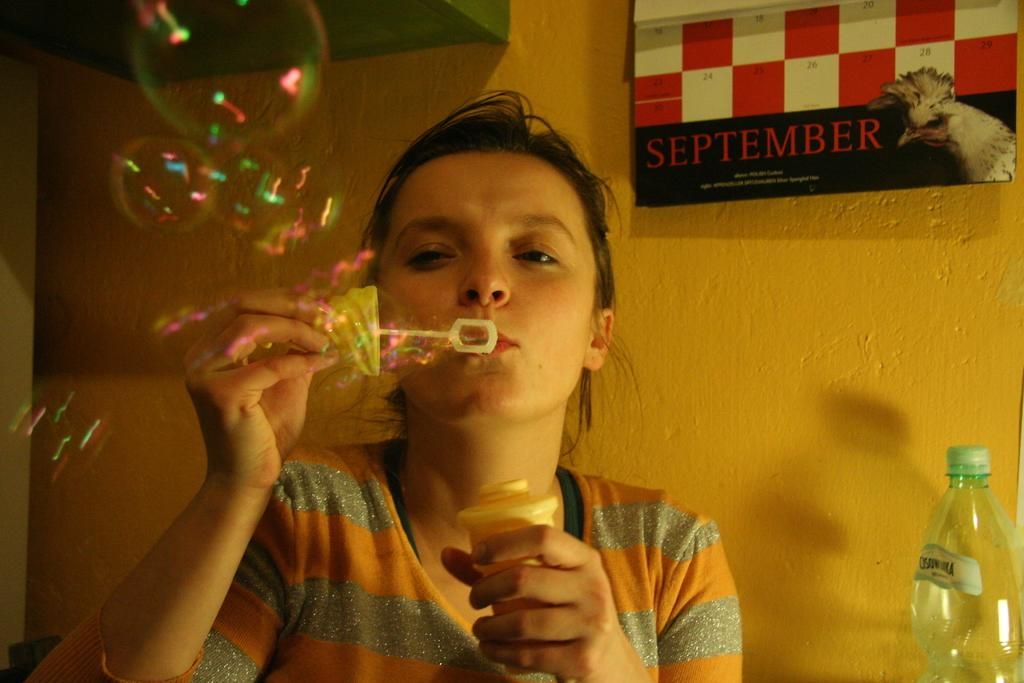What color is the wall that is visible in the image? There is an orange color wall in the image. What object can be seen on the wall in the image? There is a bottle in the image. What is hanging on the wall in the image? There is a banner in the image. Who is present in the image? There is a woman in the image. What is the woman doing in the image? The woman is blowing bubbles. Can you see any animals on the moon in the image? There are no animals or moons present in the image; it features an orange wall, a bottle, a banner, a woman blowing bubbles, and no mention of a plough. 